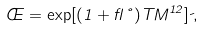<formula> <loc_0><loc_0><loc_500><loc_500>\phi = \exp [ ( 1 + \gamma \nu ) T M ^ { 1 2 } ] \psi ,</formula> 